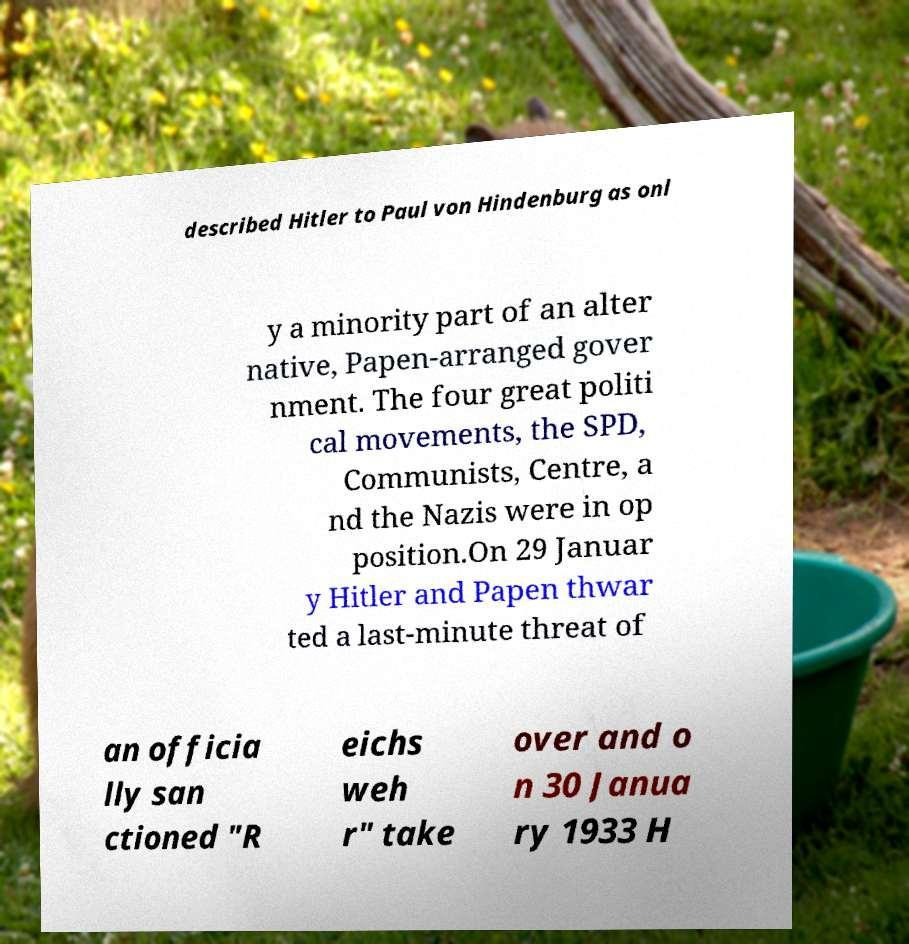Can you read and provide the text displayed in the image?This photo seems to have some interesting text. Can you extract and type it out for me? described Hitler to Paul von Hindenburg as onl y a minority part of an alter native, Papen-arranged gover nment. The four great politi cal movements, the SPD, Communists, Centre, a nd the Nazis were in op position.On 29 Januar y Hitler and Papen thwar ted a last-minute threat of an officia lly san ctioned "R eichs weh r" take over and o n 30 Janua ry 1933 H 